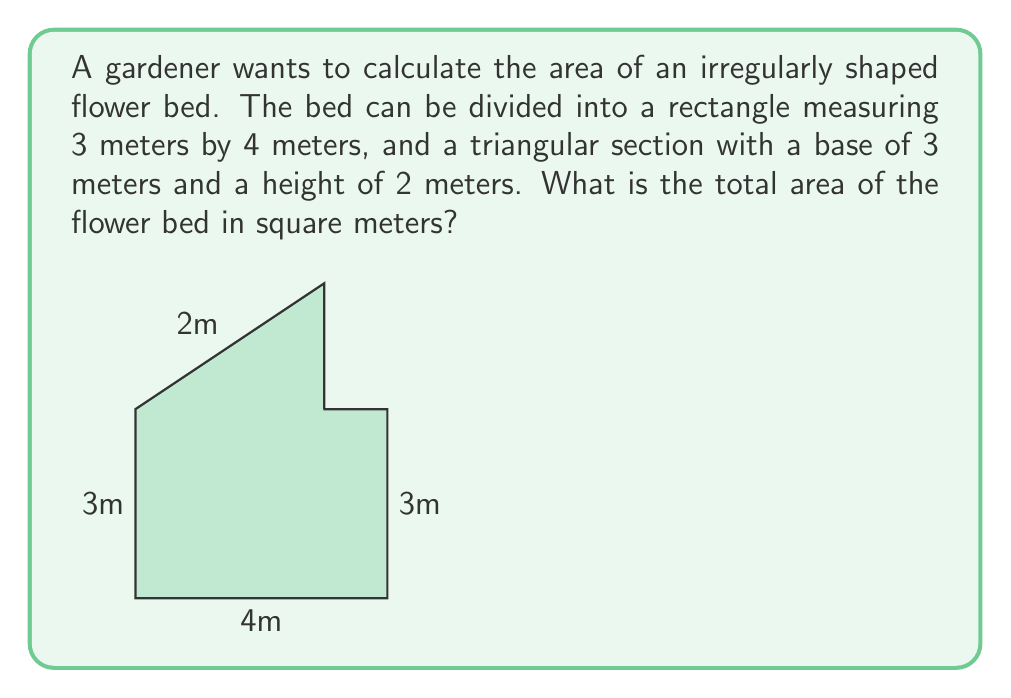Can you answer this question? To calculate the total area of the irregularly shaped flower bed, we need to:

1. Calculate the area of the rectangular section:
   $$A_{rectangle} = length \times width = 4\text{ m} \times 3\text{ m} = 12\text{ m}^2$$

2. Calculate the area of the triangular section:
   $$A_{triangle} = \frac{1}{2} \times base \times height = \frac{1}{2} \times 3\text{ m} \times 2\text{ m} = 3\text{ m}^2$$

3. Sum up the areas of both sections:
   $$A_{total} = A_{rectangle} + A_{triangle} = 12\text{ m}^2 + 3\text{ m}^2 = 15\text{ m}^2$$

Therefore, the total area of the irregularly shaped flower bed is 15 square meters.
Answer: $15\text{ m}^2$ 